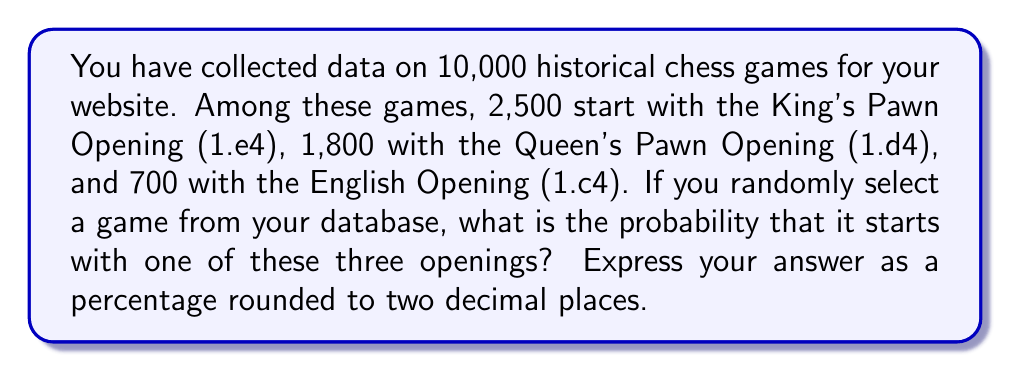Can you answer this question? To solve this problem, we need to follow these steps:

1. Calculate the total number of games that start with one of the three specified openings:
   $$n_{total} = n_{e4} + n_{d4} + n_{c4}$$
   $$n_{total} = 2500 + 1800 + 700 = 5000$$

2. Calculate the probability by dividing the number of games with these openings by the total number of games:
   $$P(\text{opening is e4, d4, or c4}) = \frac{n_{total}}{N}$$
   Where $N$ is the total number of games in the database.

   $$P(\text{opening is e4, d4, or c4}) = \frac{5000}{10000} = 0.5$$

3. Convert the probability to a percentage:
   $$\text{Percentage} = P \times 100\% = 0.5 \times 100\% = 50\%$$

The probability is already rounded to two decimal places, so no further rounding is necessary.
Answer: 50.00% 